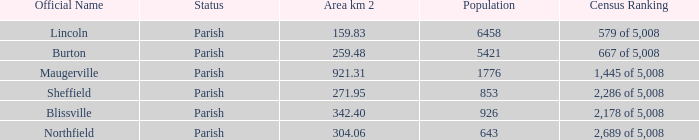What are the official name(s) of places with an area of 304.06 km2? Northfield. 